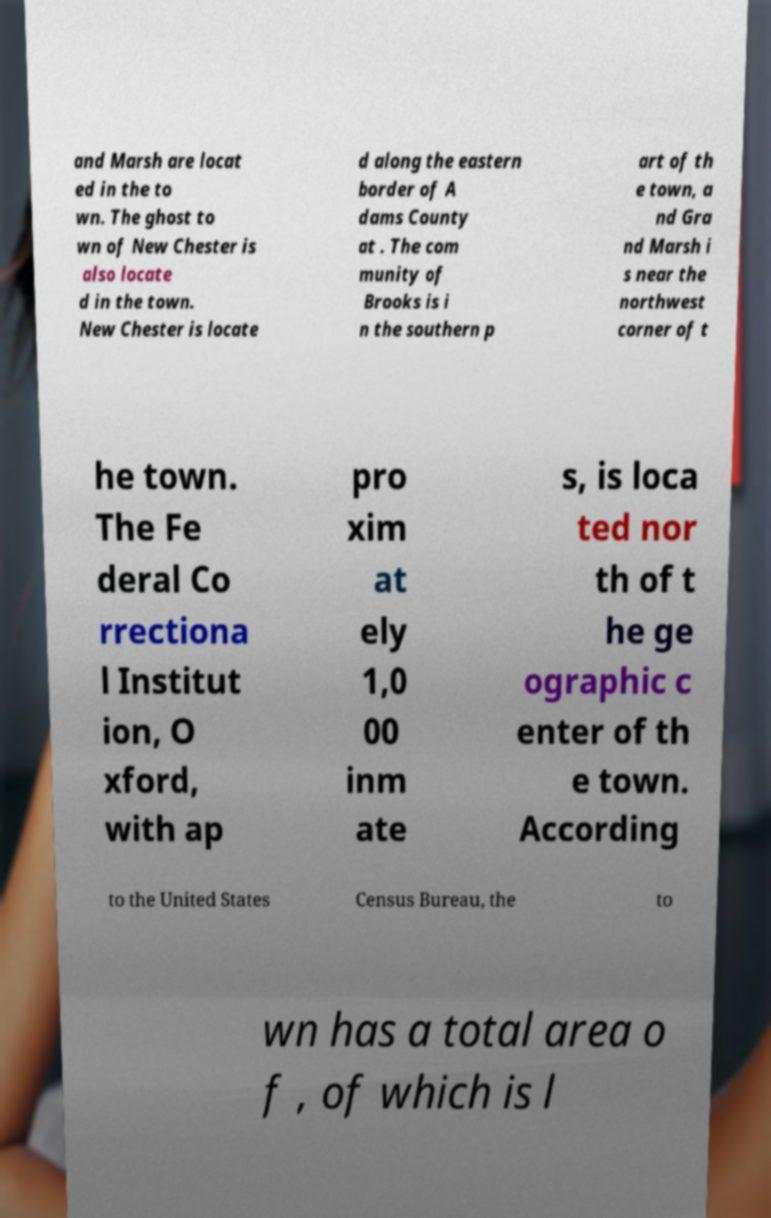Can you read and provide the text displayed in the image?This photo seems to have some interesting text. Can you extract and type it out for me? and Marsh are locat ed in the to wn. The ghost to wn of New Chester is also locate d in the town. New Chester is locate d along the eastern border of A dams County at . The com munity of Brooks is i n the southern p art of th e town, a nd Gra nd Marsh i s near the northwest corner of t he town. The Fe deral Co rrectiona l Institut ion, O xford, with ap pro xim at ely 1,0 00 inm ate s, is loca ted nor th of t he ge ographic c enter of th e town. According to the United States Census Bureau, the to wn has a total area o f , of which is l 